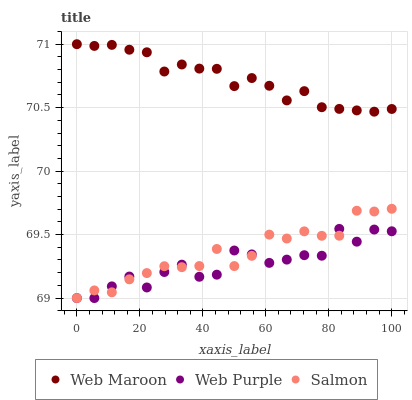Does Web Purple have the minimum area under the curve?
Answer yes or no. Yes. Does Web Maroon have the maximum area under the curve?
Answer yes or no. Yes. Does Web Maroon have the minimum area under the curve?
Answer yes or no. No. Does Web Purple have the maximum area under the curve?
Answer yes or no. No. Is Web Maroon the smoothest?
Answer yes or no. Yes. Is Web Purple the roughest?
Answer yes or no. Yes. Is Web Purple the smoothest?
Answer yes or no. No. Is Web Maroon the roughest?
Answer yes or no. No. Does Salmon have the lowest value?
Answer yes or no. Yes. Does Web Maroon have the lowest value?
Answer yes or no. No. Does Web Maroon have the highest value?
Answer yes or no. Yes. Does Web Purple have the highest value?
Answer yes or no. No. Is Salmon less than Web Maroon?
Answer yes or no. Yes. Is Web Maroon greater than Web Purple?
Answer yes or no. Yes. Does Salmon intersect Web Purple?
Answer yes or no. Yes. Is Salmon less than Web Purple?
Answer yes or no. No. Is Salmon greater than Web Purple?
Answer yes or no. No. Does Salmon intersect Web Maroon?
Answer yes or no. No. 